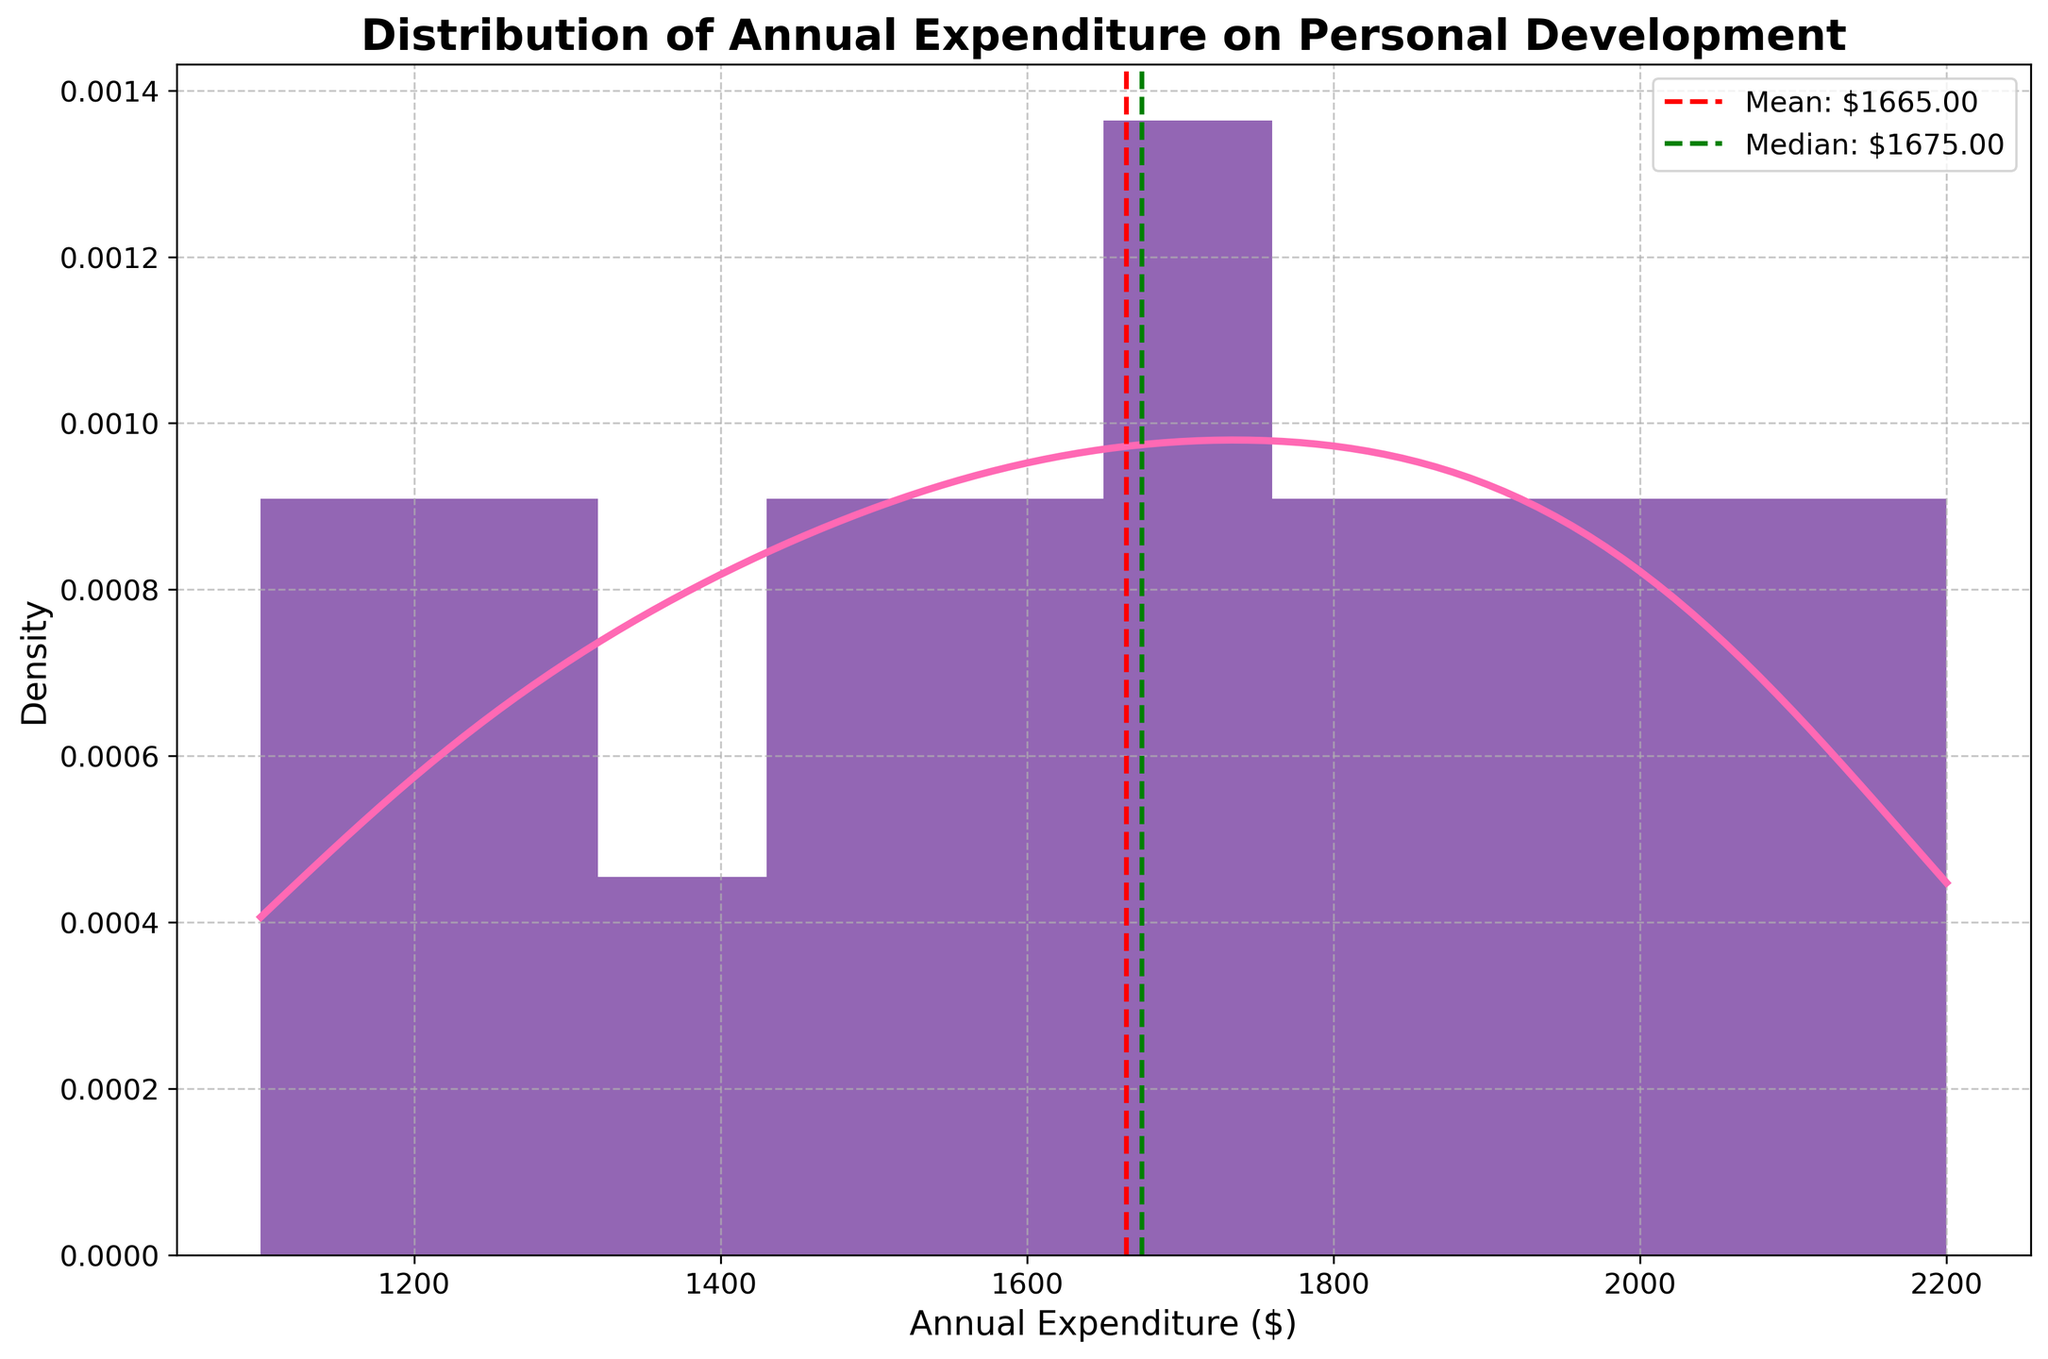What is the title of the figure? The title is located at the top of the figure and reads "Distribution of Annual Expenditure on Personal Development".
Answer: Distribution of Annual Expenditure on Personal Development What are the x-axis and y-axis labels? The x-axis label is "Annual Expenditure ($)" and the y-axis label is "Density", as indicated on the respective axes.
Answer: Annual Expenditure ($) and Density Which color is used for the histogram in the figure? The histogram bars are shaded in a purplish color, making them distinct from other elements in the figure.
Answer: Purplish color What is the mean annual expenditure on personal development? The mean value is shown by a red dashed line on the plot with a label. The label indicates that the mean annual expenditure is approximately $1637.50.
Answer: $1637.50 What is the median annual expenditure on personal development? The median value is shown by a green dashed line on the plot with a label. The label indicates that the median annual expenditure is approximately $1650.00.
Answer: $1650.00 Are the mean and median annual expenditures close to each other in value? The mean is $1637.50 and the median is $1650.00, so they are very close in value, differing only by about $12.50.
Answer: Yes, they are close What statistical feature does the red dashed line represent? The red dashed line represents the mean value of the annual expenditures, as indicated by the label "Mean: $1637.50".
Answer: Mean What statistical feature does the green dashed line represent? The green dashed line represents the median value of the annual expenditures, as indicated by the label "Median: $1650.00".
Answer: Median Does the distribution appear to be symmetric or skewed? The distribution appears to be relatively symmetrical, as the mean and median are close and the shape of the distribution does not deviate significantly to one side.
Answer: Symmetric Which individual has the highest annual expenditure on personal development? By examining the provided data, Harper Young has the highest annual expenditure of $2200.
Answer: Harper Young 